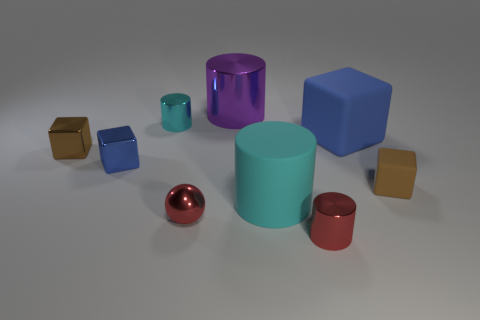Subtract 1 cylinders. How many cylinders are left? 3 Add 1 yellow matte balls. How many objects exist? 10 Subtract all cylinders. How many objects are left? 5 Subtract 2 brown cubes. How many objects are left? 7 Subtract all balls. Subtract all big purple metal objects. How many objects are left? 7 Add 2 large metal cylinders. How many large metal cylinders are left? 3 Add 8 metallic spheres. How many metallic spheres exist? 9 